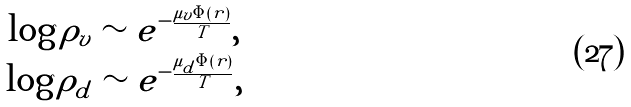<formula> <loc_0><loc_0><loc_500><loc_500>\begin{array} { c } \log \rho _ { v } \sim e ^ { - \frac { \mu _ { v } \Phi ( r ) } { T } } , \\ \log \rho _ { d } \sim e ^ { - \frac { \mu _ { d } \Phi ( r ) } { T } } , \end{array}</formula> 